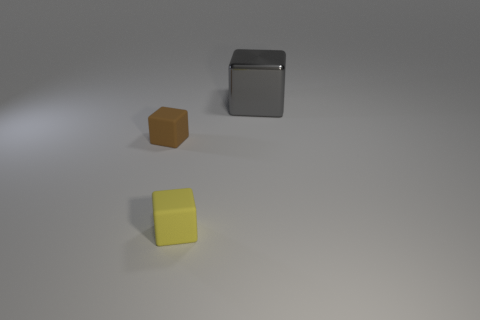Subtract all tiny brown cubes. How many cubes are left? 2 Add 1 tiny gray matte cylinders. How many objects exist? 4 Subtract 2 cubes. How many cubes are left? 1 Subtract all gray blocks. How many blocks are left? 2 Add 1 small blocks. How many small blocks are left? 3 Add 2 small brown cubes. How many small brown cubes exist? 3 Subtract 0 blue cubes. How many objects are left? 3 Subtract all cyan cubes. Subtract all yellow cylinders. How many cubes are left? 3 Subtract all yellow cylinders. How many green cubes are left? 0 Subtract all yellow cubes. Subtract all brown rubber cubes. How many objects are left? 1 